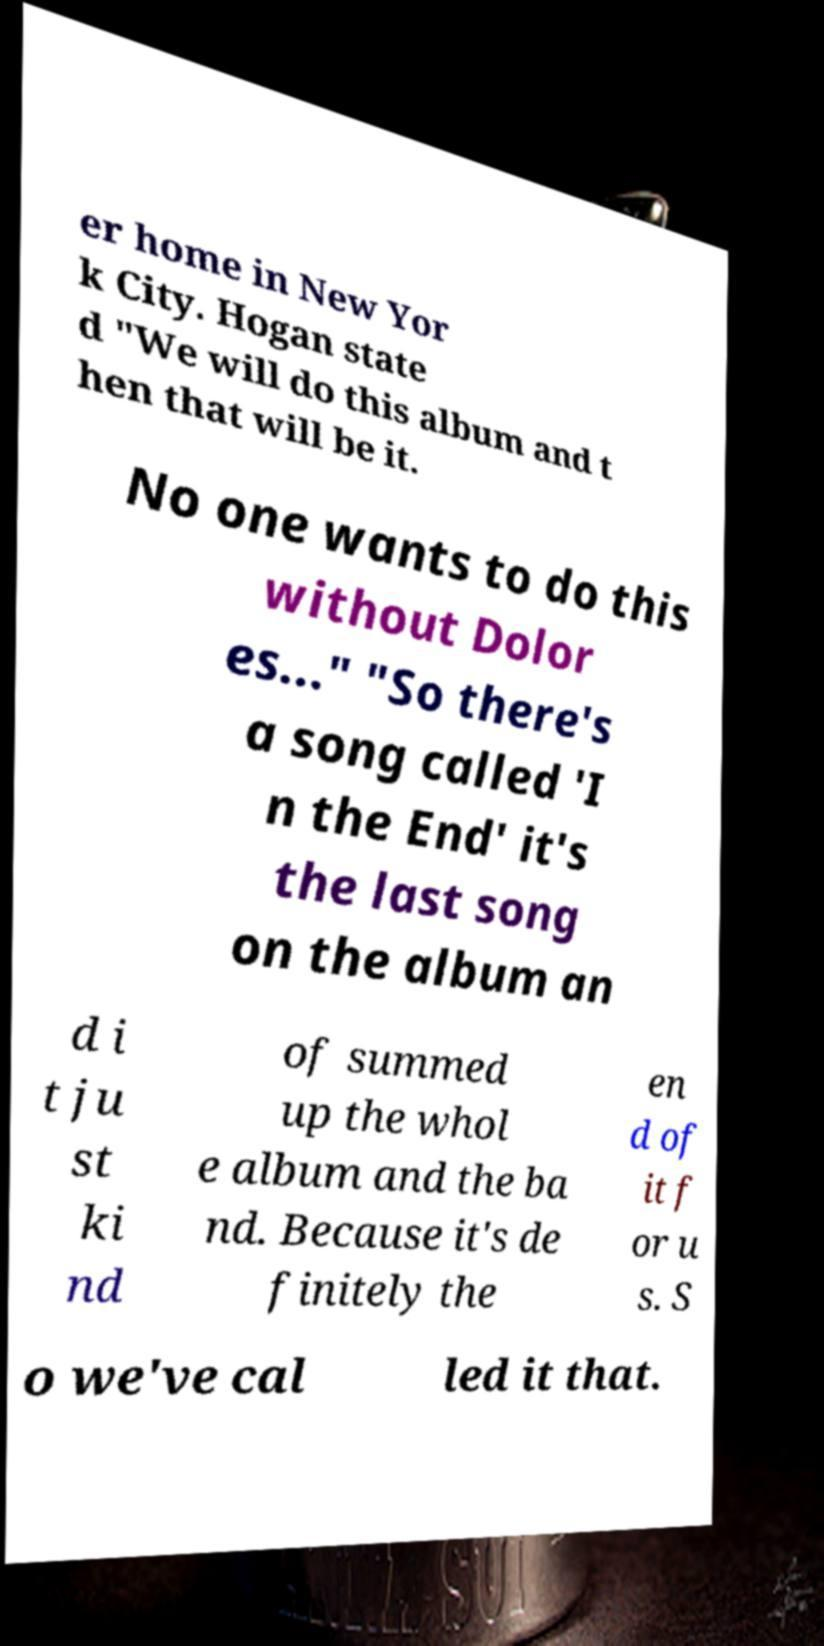Can you accurately transcribe the text from the provided image for me? er home in New Yor k City. Hogan state d "We will do this album and t hen that will be it. No one wants to do this without Dolor es..." "So there's a song called 'I n the End' it's the last song on the album an d i t ju st ki nd of summed up the whol e album and the ba nd. Because it's de finitely the en d of it f or u s. S o we've cal led it that. 